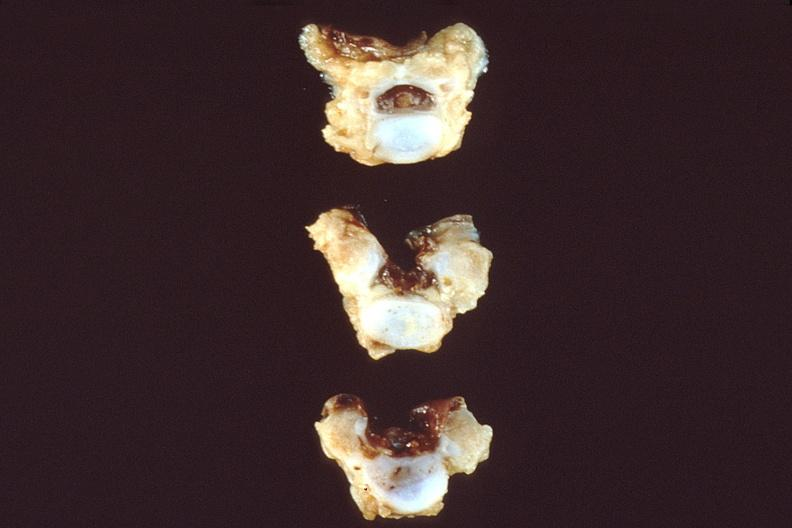does this image show neural tube defect, vertebral bodies?
Answer the question using a single word or phrase. Yes 